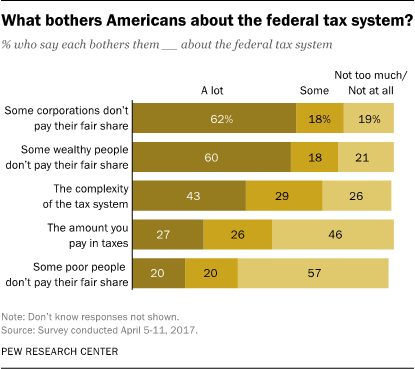Give some essential details in this illustration. I have found the category, and the value is 27, 26, 46. The amount of taxes that I will be paying is... The average score for students in the bottom 3 category is 25. 